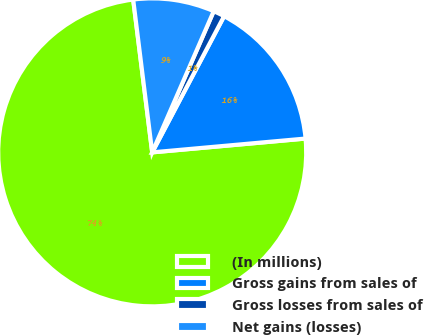<chart> <loc_0><loc_0><loc_500><loc_500><pie_chart><fcel>(In millions)<fcel>Gross gains from sales of<fcel>Gross losses from sales of<fcel>Net gains (losses)<nl><fcel>74.46%<fcel>15.84%<fcel>1.19%<fcel>8.51%<nl></chart> 